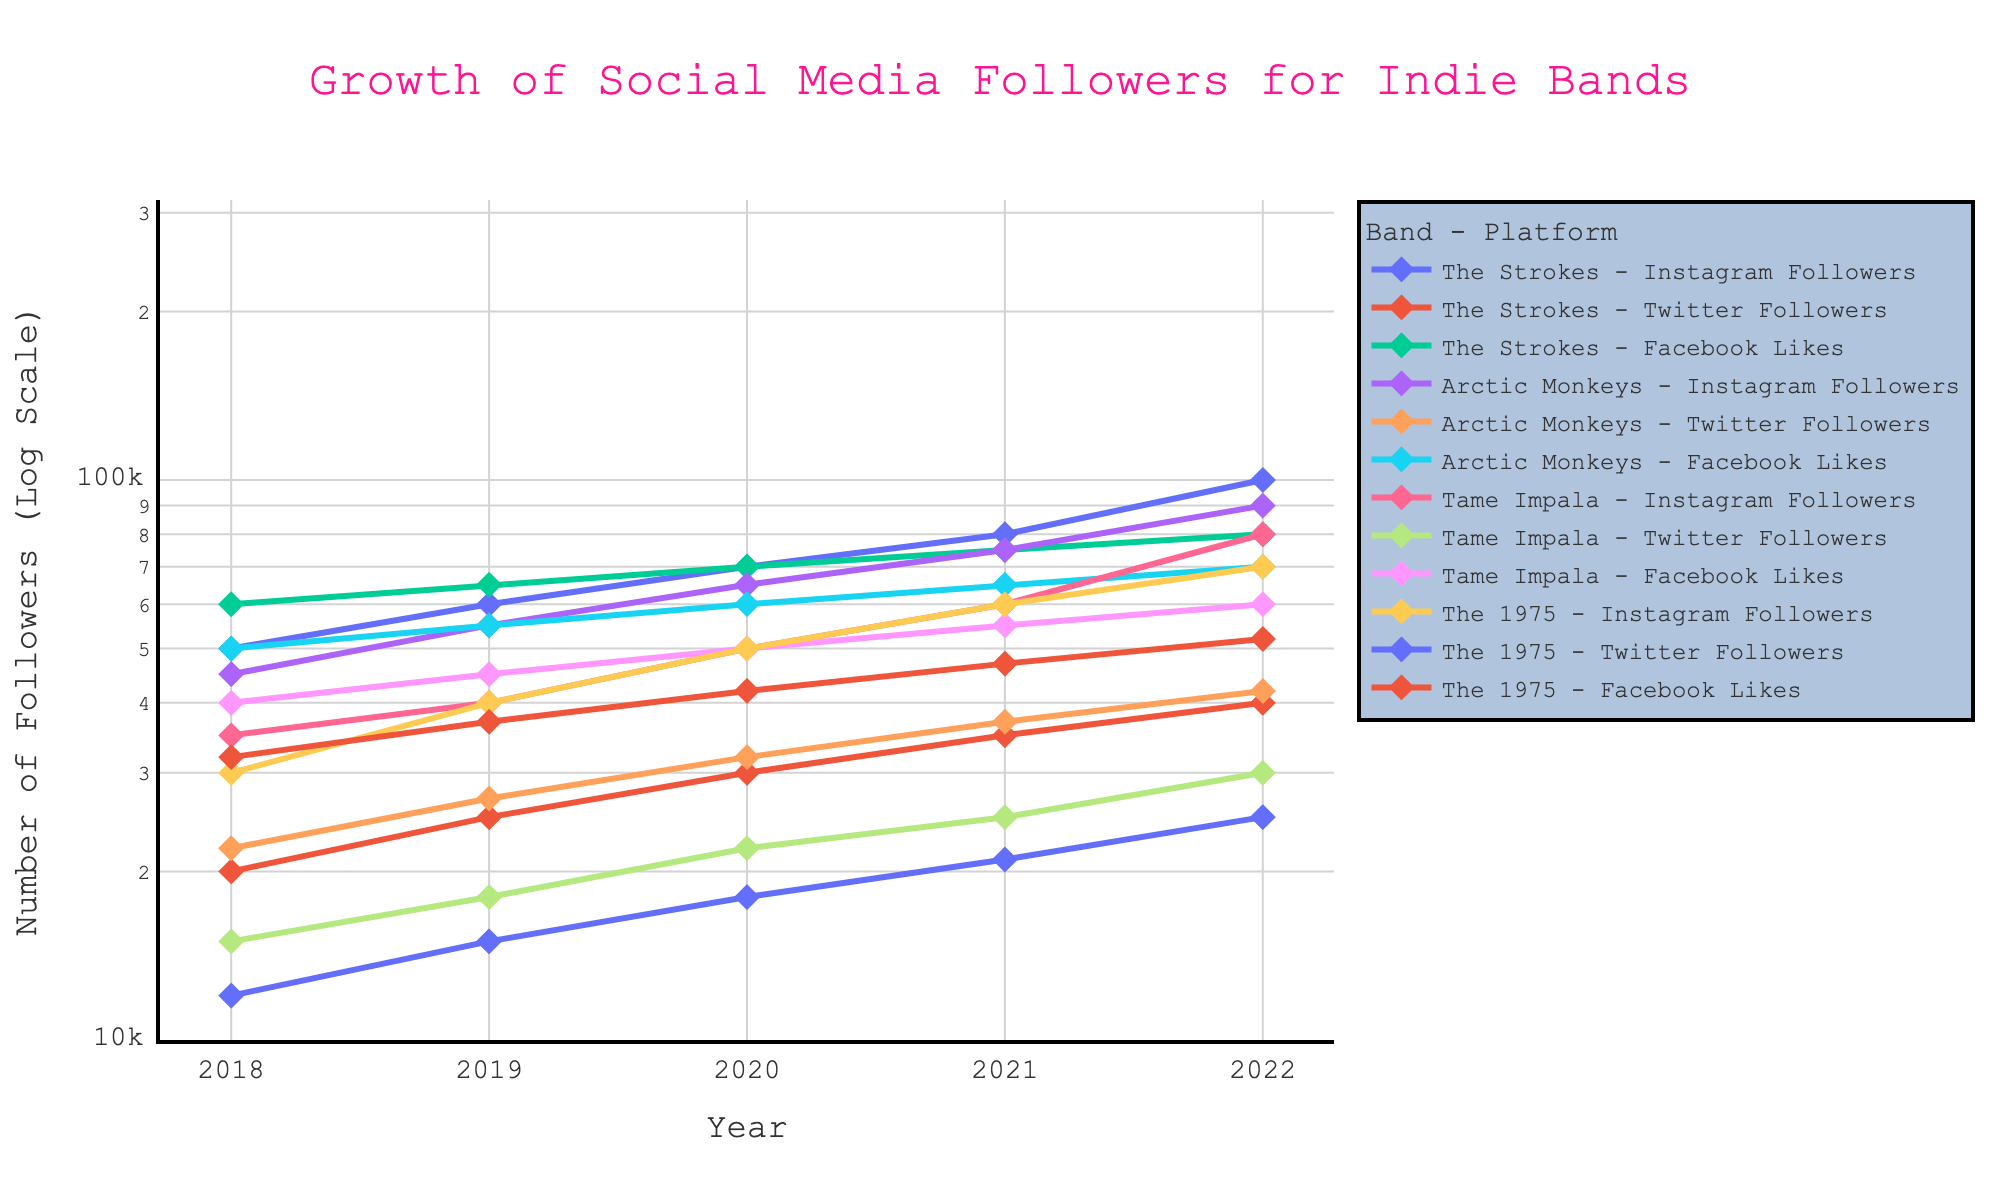What is the title of the figure? The title is usually located at the top of the plot. You can refer to it to understand what the graph represents.
Answer: Growth of Social Media Followers for Indie Bands What is the y-axis title of the figure? The y-axis title is positioned along the vertical axis and typically indicates what the numbers on this axis represent.
Answer: Number of Followers (Log Scale) Which band had the highest number of Instagram followers in 2022? By looking at the y-values for each band's Instagram followers in the year 2022, you can identify which one is the highest.
Answer: The Strokes How did The 1975's Facebook likes change from 2018 to 2022? To determine the change, you need to look at the y-values for Facebook likes for The 1975 in 2018 and 2022 and compare them.
Answer: Increased from 32,000 to 52,000 Out of Arctic Monkeys and Tame Impala, which band had more Twitter followers in 2020? You need to compare the y-values for Twitter followers for both Arctic Monkeys and Tame Impala in the year 2020.
Answer: Arctic Monkeys Which social media platform shows the most significant follower growth for The Strokes between 2018 and 2022? Calculate the difference in followers from 2018 to 2022 for each platform (Instagram, Twitter, Facebook) and see which has the highest increase.
Answer: Instagram For which band does the number of Twitter followers consistently increase every year from 2018 to 2022? By checking the trend of Twitter followers year by year for each band, determine which one shows a continuous increase.
Answer: Arctic Monkeys Between 2020 and 2021, which band had the largest percentage increase in Instagram followers? Calculate the percentage increase for Instagram followers for each band between 2020 and 2021 and identify the largest one.
Answer: The 1975 How does the growth rate of Facebook likes for Tame Impala compare to that of The 1975 from 2018 to 2022? To compare growth rates, analyze the increase in Facebook likes for both bands over the given period and see which has a higher rate.
Answer: Tame Impala What's the range of the followers on the y-axis for the entire plot? Look at the minimum and maximum values on the y-axis to determine the range.
Answer: From 10,000 to 100,000 